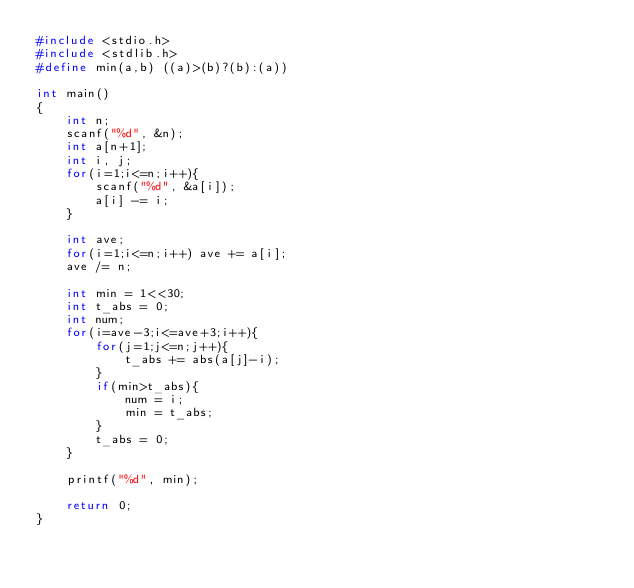<code> <loc_0><loc_0><loc_500><loc_500><_C_>#include <stdio.h>
#include <stdlib.h>
#define min(a,b) ((a)>(b)?(b):(a))

int main()
{
    int n;
    scanf("%d", &n);
    int a[n+1];
    int i, j;
    for(i=1;i<=n;i++){
        scanf("%d", &a[i]);
        a[i] -= i;
    }
    
    int ave;
    for(i=1;i<=n;i++) ave += a[i];
    ave /= n;
    
    int min = 1<<30;
    int t_abs = 0;
    int num;
    for(i=ave-3;i<=ave+3;i++){
        for(j=1;j<=n;j++){
            t_abs += abs(a[j]-i);
        }
        if(min>t_abs){
            num = i;
            min = t_abs;
        }
        t_abs = 0;
    }
    
    printf("%d", min);

    return 0;
}</code> 